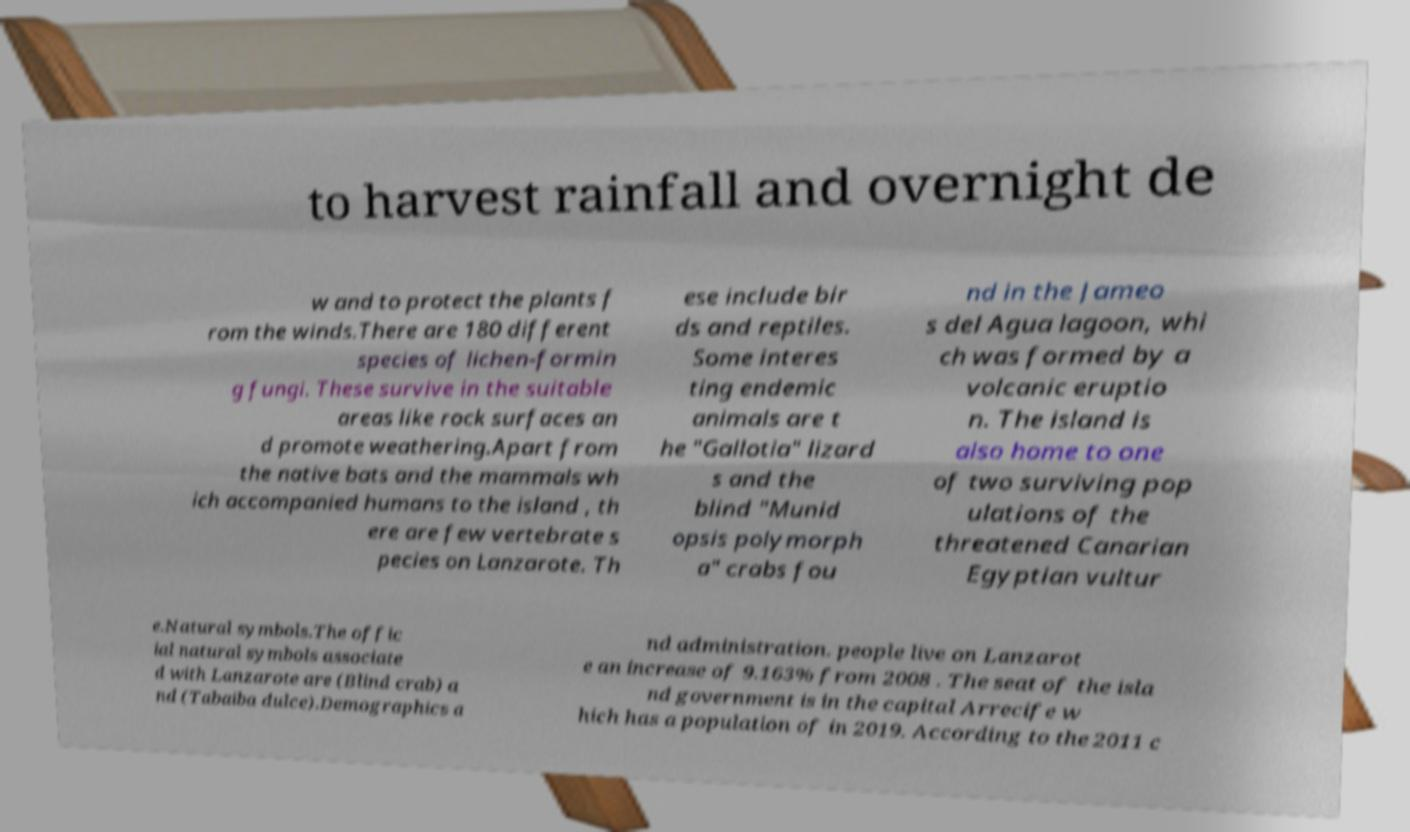Please identify and transcribe the text found in this image. to harvest rainfall and overnight de w and to protect the plants f rom the winds.There are 180 different species of lichen-formin g fungi. These survive in the suitable areas like rock surfaces an d promote weathering.Apart from the native bats and the mammals wh ich accompanied humans to the island , th ere are few vertebrate s pecies on Lanzarote. Th ese include bir ds and reptiles. Some interes ting endemic animals are t he "Gallotia" lizard s and the blind "Munid opsis polymorph a" crabs fou nd in the Jameo s del Agua lagoon, whi ch was formed by a volcanic eruptio n. The island is also home to one of two surviving pop ulations of the threatened Canarian Egyptian vultur e.Natural symbols.The offic ial natural symbols associate d with Lanzarote are (Blind crab) a nd (Tabaiba dulce).Demographics a nd administration. people live on Lanzarot e an increase of 9.163% from 2008 . The seat of the isla nd government is in the capital Arrecife w hich has a population of in 2019. According to the 2011 c 